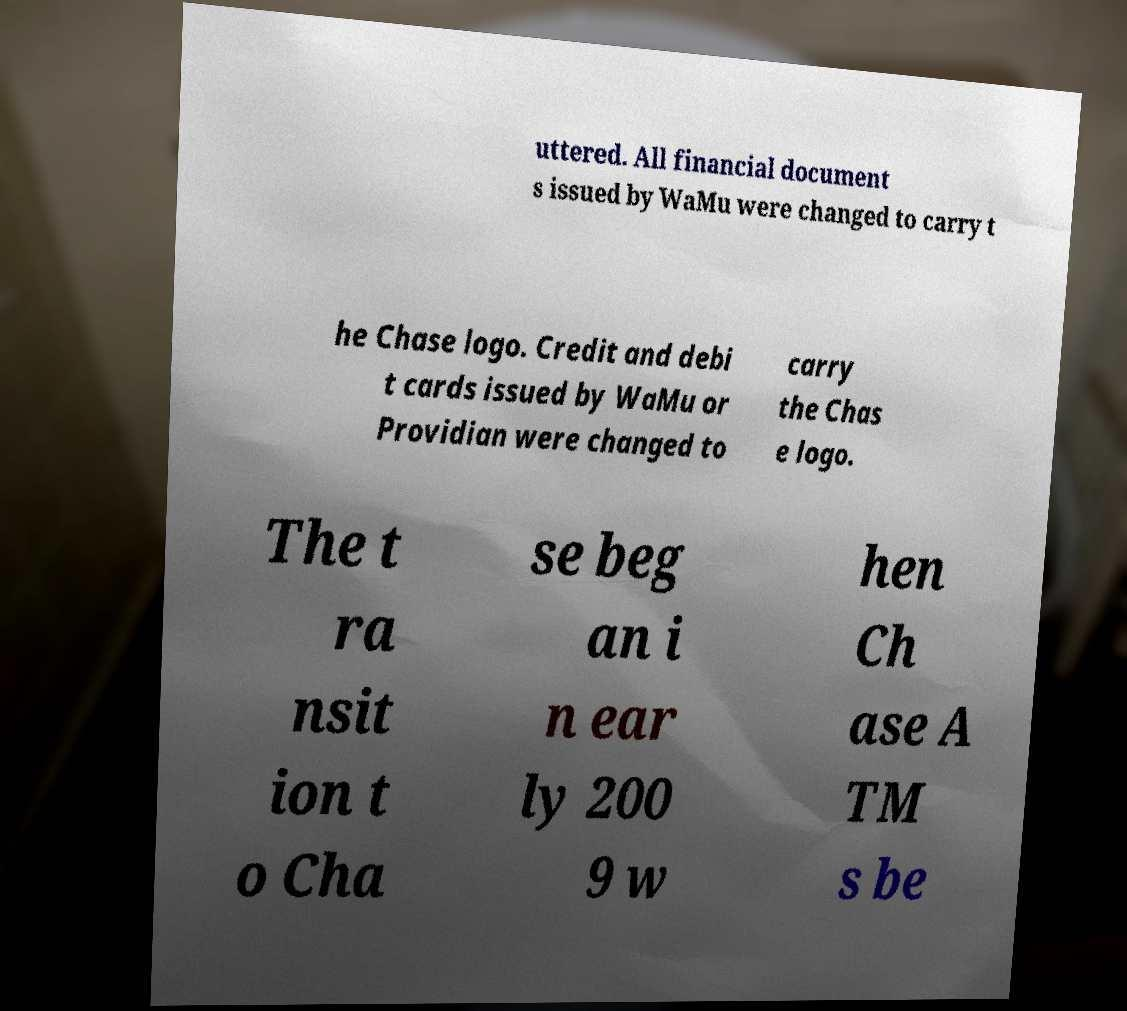Can you accurately transcribe the text from the provided image for me? uttered. All financial document s issued by WaMu were changed to carry t he Chase logo. Credit and debi t cards issued by WaMu or Providian were changed to carry the Chas e logo. The t ra nsit ion t o Cha se beg an i n ear ly 200 9 w hen Ch ase A TM s be 